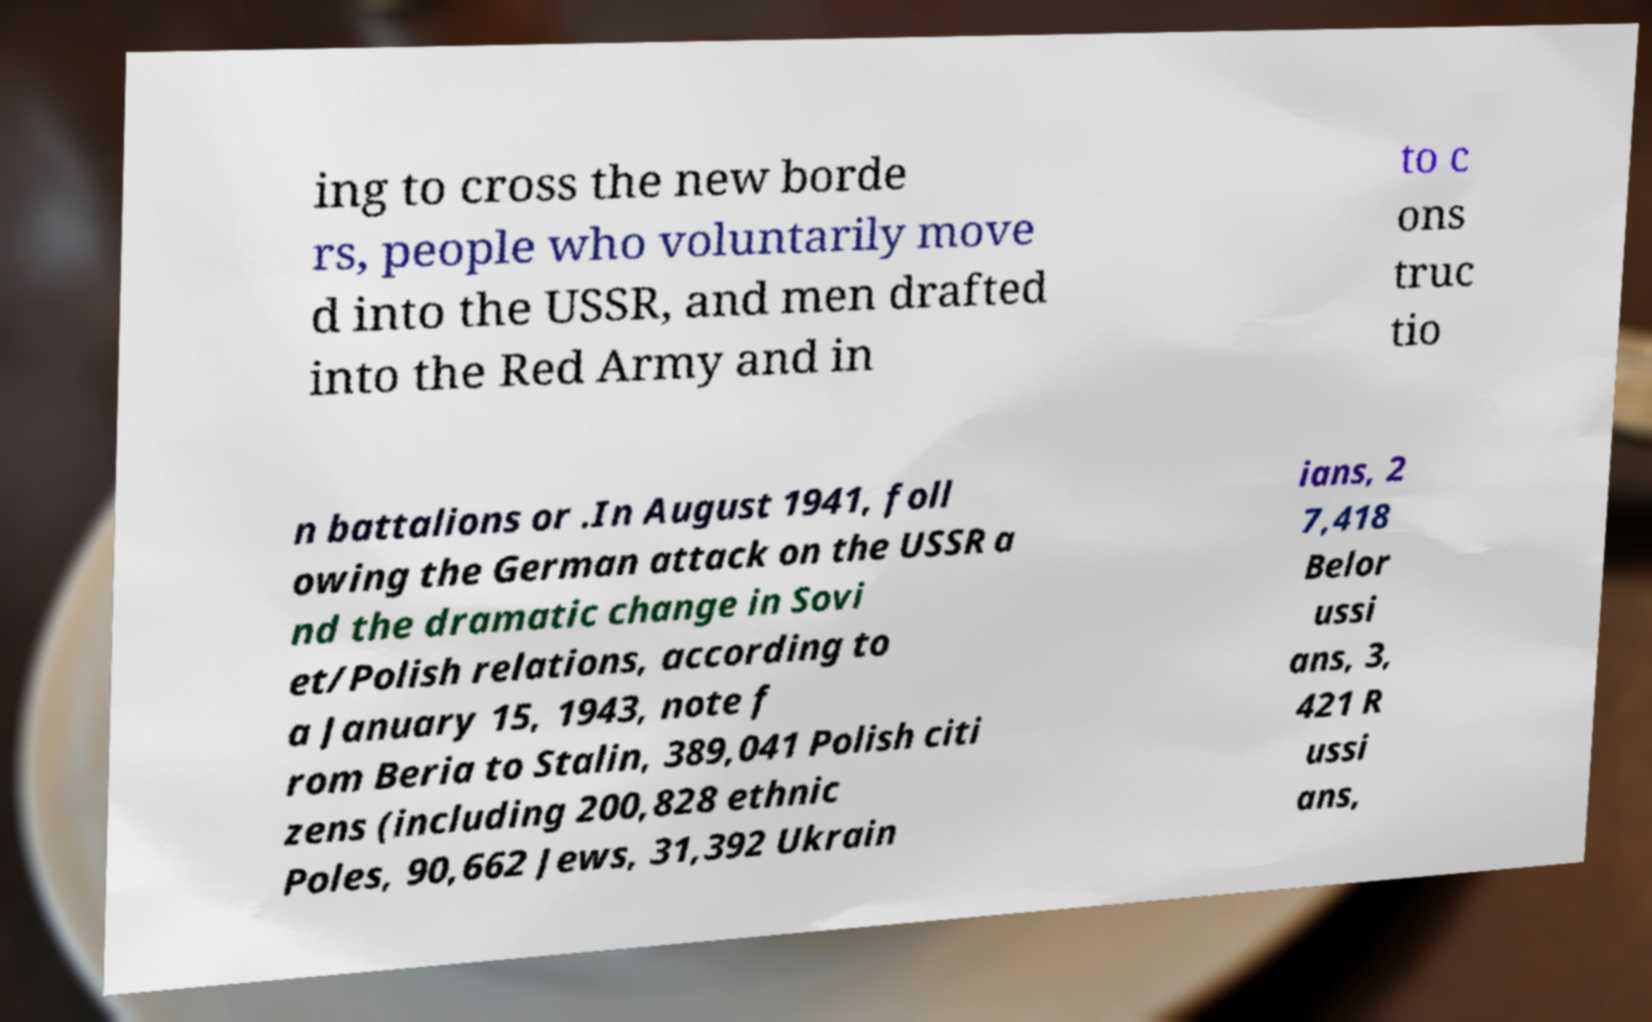Can you read and provide the text displayed in the image?This photo seems to have some interesting text. Can you extract and type it out for me? ing to cross the new borde rs, people who voluntarily move d into the USSR, and men drafted into the Red Army and in to c ons truc tio n battalions or .In August 1941, foll owing the German attack on the USSR a nd the dramatic change in Sovi et/Polish relations, according to a January 15, 1943, note f rom Beria to Stalin, 389,041 Polish citi zens (including 200,828 ethnic Poles, 90,662 Jews, 31,392 Ukrain ians, 2 7,418 Belor ussi ans, 3, 421 R ussi ans, 